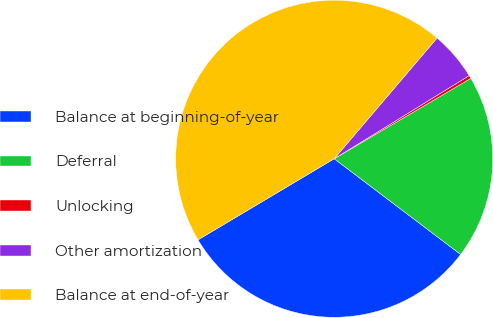Convert chart. <chart><loc_0><loc_0><loc_500><loc_500><pie_chart><fcel>Balance at beginning-of-year<fcel>Deferral<fcel>Unlocking<fcel>Other amortization<fcel>Balance at end-of-year<nl><fcel>31.14%<fcel>18.78%<fcel>0.32%<fcel>4.98%<fcel>44.78%<nl></chart> 